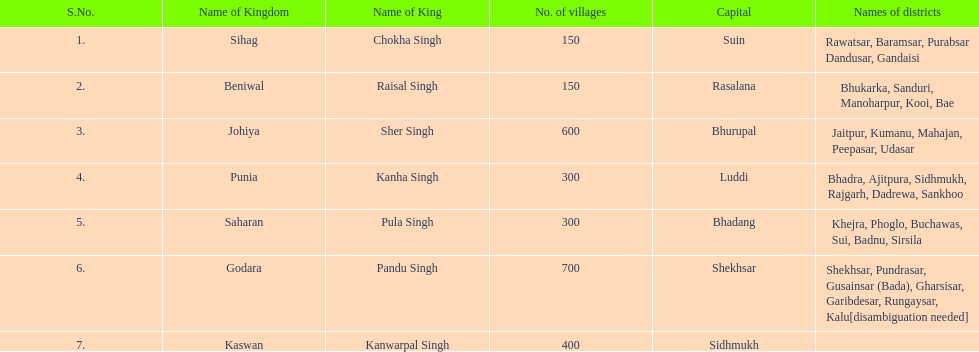Who was the ruler of the sihag kingdom? Chokha Singh. 